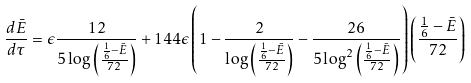<formula> <loc_0><loc_0><loc_500><loc_500>\frac { d \bar { E } } { d \tau } = \epsilon \frac { 1 2 } { 5 \log \left ( \frac { \frac { 1 } { 6 } - \bar { E } } { 7 2 } \right ) } + 1 4 4 \epsilon \left ( 1 - \frac { 2 } { \log \left ( \frac { \frac { 1 } { 6 } - \bar { E } } { 7 2 } \right ) } - \frac { 2 6 } { 5 \log ^ { 2 } \left ( \frac { \frac { 1 } { 6 } - \bar { E } } { 7 2 } \right ) } \right ) \left ( \frac { \frac { 1 } { 6 } - \bar { E } } { 7 2 } \right )</formula> 